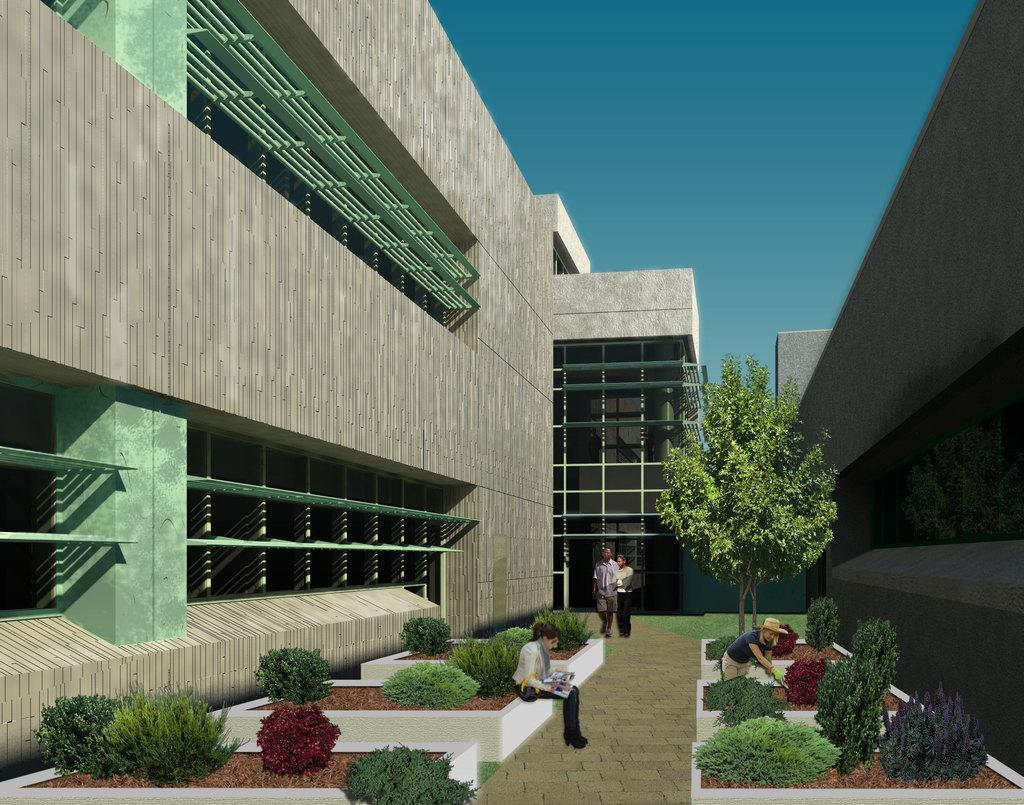What type of living organisms can be seen in the image? Plants and trees are visible in the image. What type of structures can be seen in the image? There are buildings in the image. Are there any people present in the image? Yes, there are persons in the image. What type of clock can be seen hanging from the tree in the image? There is no clock present in the image, and no clock is hanging from any tree. 